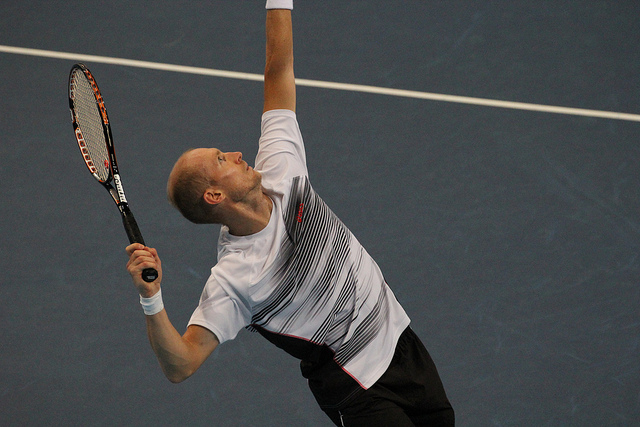<image>What brand is the man's shirt? I don't know the exact brand of the man's shirt. However, it could be 'under armour', 'adidas', 'nike' or 'inca'. What brand is the man's shirt? I don't know what brand is the man's shirt. It could be Under Armour, Adidas, Nike, or Inca. 